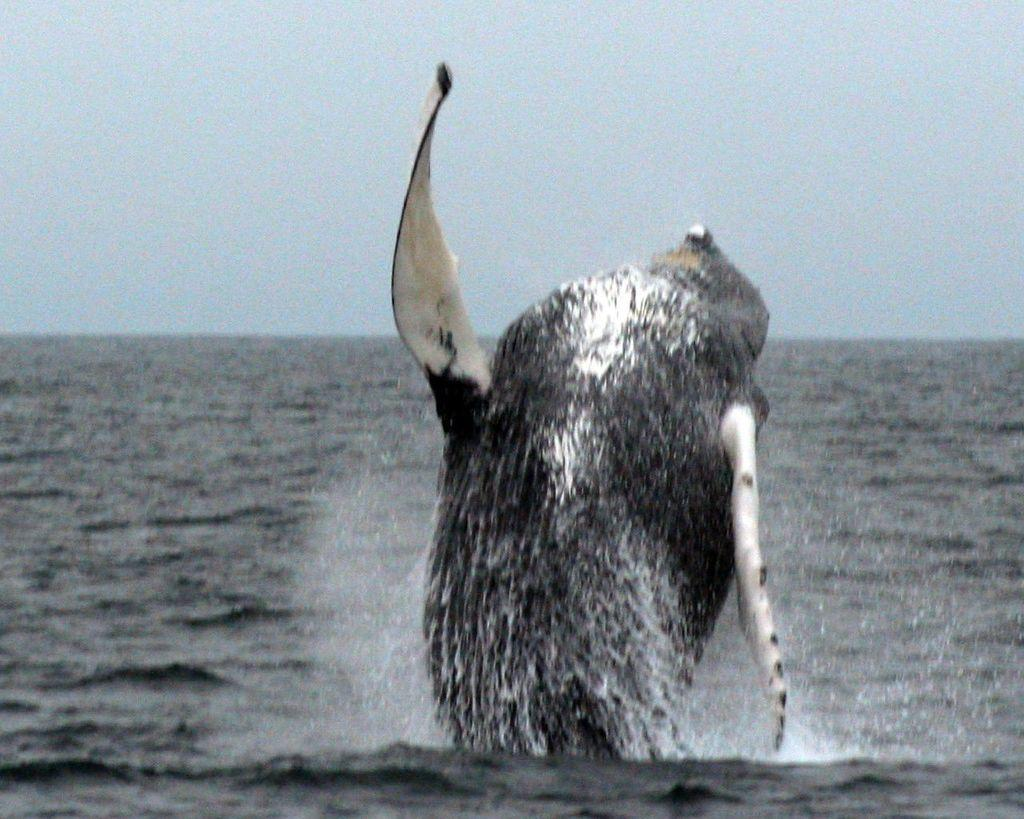What can be seen in the background of the image? The sky is visible in the background of the image. What is present in the image besides the sky? There is water and a water animal in the image. What type of kite is being flown by the judge in the image? There is no kite or judge present in the image; it features a water animal in the water. 